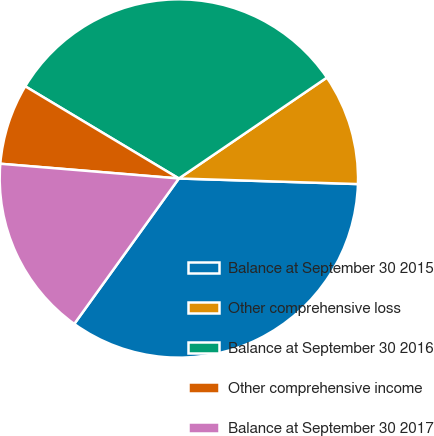Convert chart. <chart><loc_0><loc_0><loc_500><loc_500><pie_chart><fcel>Balance at September 30 2015<fcel>Other comprehensive loss<fcel>Balance at September 30 2016<fcel>Other comprehensive income<fcel>Balance at September 30 2017<nl><fcel>34.43%<fcel>10.02%<fcel>31.88%<fcel>7.29%<fcel>16.39%<nl></chart> 